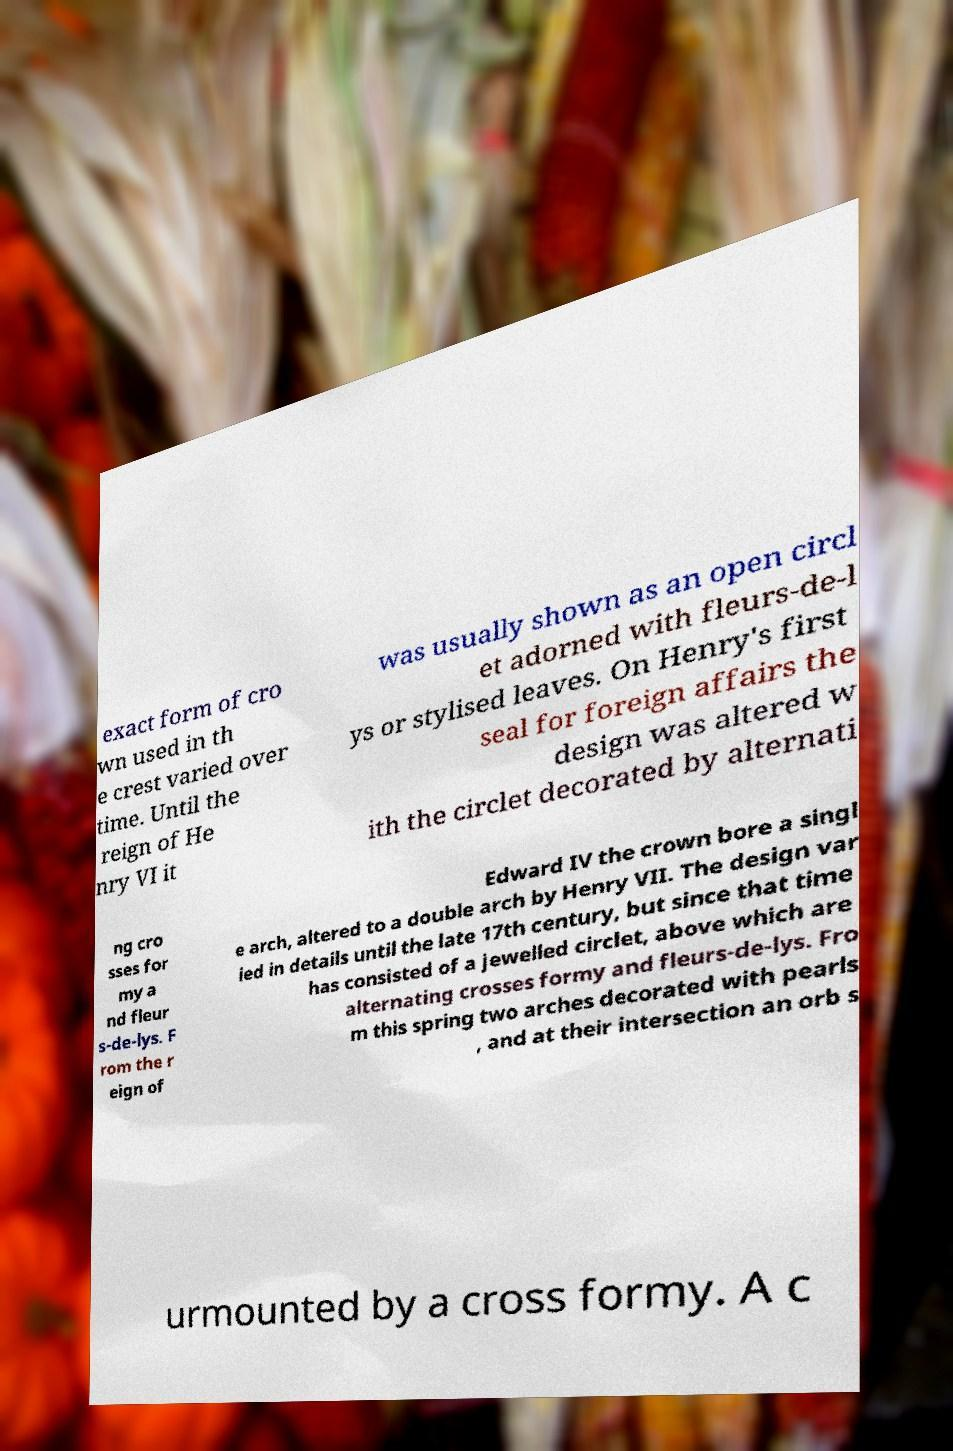There's text embedded in this image that I need extracted. Can you transcribe it verbatim? exact form of cro wn used in th e crest varied over time. Until the reign of He nry VI it was usually shown as an open circl et adorned with fleurs-de-l ys or stylised leaves. On Henry's first seal for foreign affairs the design was altered w ith the circlet decorated by alternati ng cro sses for my a nd fleur s-de-lys. F rom the r eign of Edward IV the crown bore a singl e arch, altered to a double arch by Henry VII. The design var ied in details until the late 17th century, but since that time has consisted of a jewelled circlet, above which are alternating crosses formy and fleurs-de-lys. Fro m this spring two arches decorated with pearls , and at their intersection an orb s urmounted by a cross formy. A c 